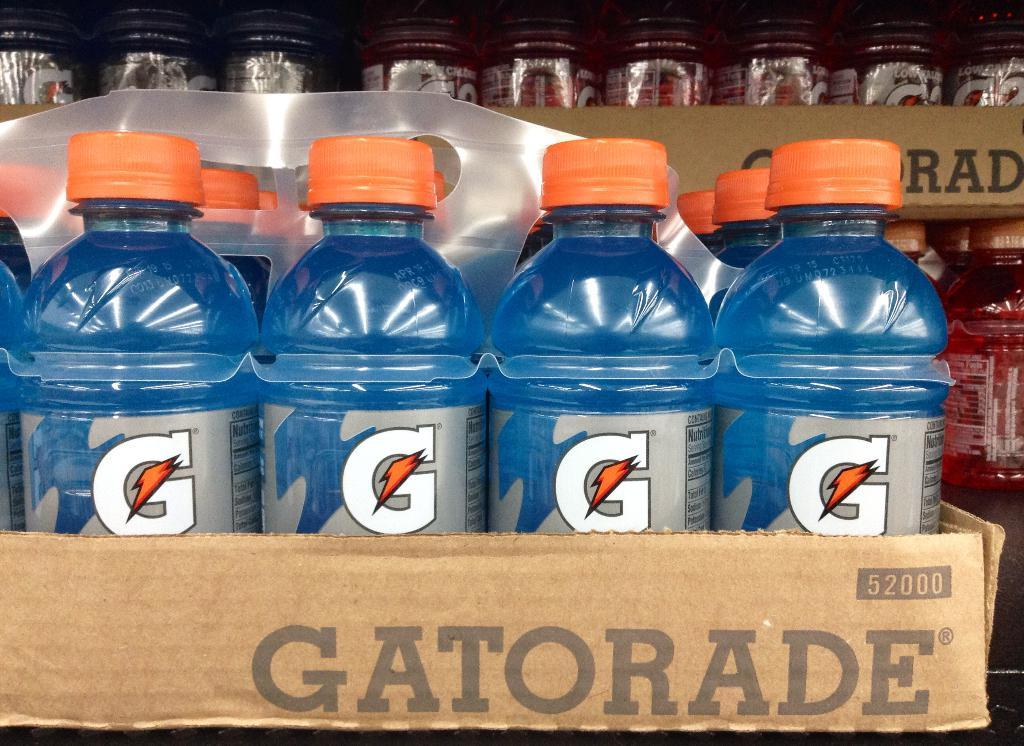<image>
Describe the image concisely. A container with a bunch of Gatorade bottles. 